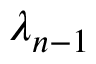Convert formula to latex. <formula><loc_0><loc_0><loc_500><loc_500>\lambda _ { n - 1 }</formula> 